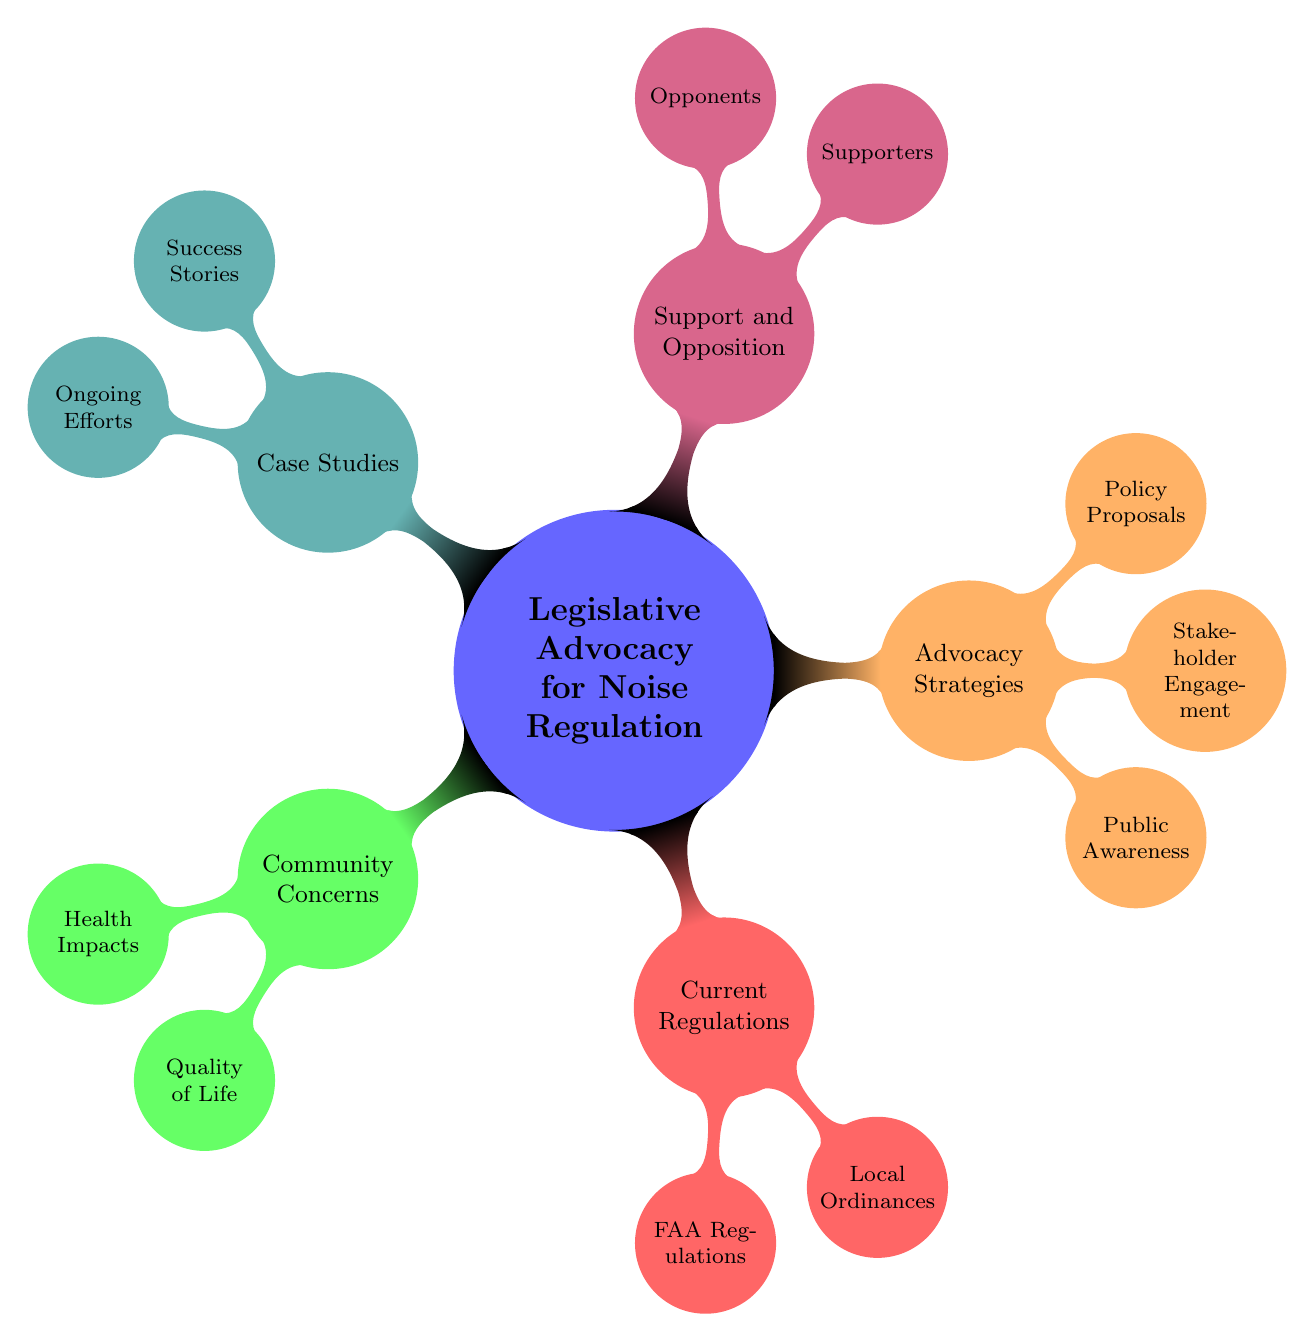What are the two main categories under Community Concerns? The main categories under Community Concerns are Health Impacts and Quality of Life. These categories are represented as child nodes beneath the Community Concerns node in the diagram.
Answer: Health Impacts, Quality of Life How many advocacy strategies are listed? The Advocacy Strategies section lists three strategies: Public Awareness, Stakeholder Engagement, and Policy Proposals. By counting these child nodes, we determine the total number of strategies.
Answer: 3 What is the primary difference between Supporters and Opponents? Supporters are identified as groups that advocate for stricter noise regulations, such as Environmental Advocates and Local Residents. In contrast, Opponents represent groups that may resist these changes, such as the Airline Industry and Airport Authorities. This distinction can be made by looking at the respective nodes and their labels.
Answer: Supporters advocate, Opponents resist Which case study involves airport curfews? Sydney Airport Curfew is mentioned specifically as an ongoing effort in the Case Studies section. It can be found as a child node under Ongoing Efforts in the diagram.
Answer: Sydney Airport Curfew What are the current regulations listed? The Current Regulations section includes two types of regulations: FAA Regulations and Local Ordinances. These are the primary categories that are depicted in this section of the mind map.
Answer: FAA Regulations, Local Ordinances How do Stakeholder Engagement and Public Awareness relate to Advocacy Strategies? Stakeholder Engagement and Public Awareness are both classified under the Advocacy Strategies node, indicating that they are methods used to promote legislative advocacy for noise regulation. Each serves a different function, with Stakeholder Engagement focusing on collaboration between various groups and Public Awareness aimed at informing residents about the issues.
Answer: They are both methods for legislative advocacy Which type of impacts are included under Health Impacts? The Health Impacts category includes Sleep Disturbance, Cardiovascular Issues, and Mental Health Stress. These specific impacts are listed as child nodes beneath the Health Impacts node in the diagram.
Answer: Sleep Disturbance, Cardiovascular Issues, Mental Health Stress 